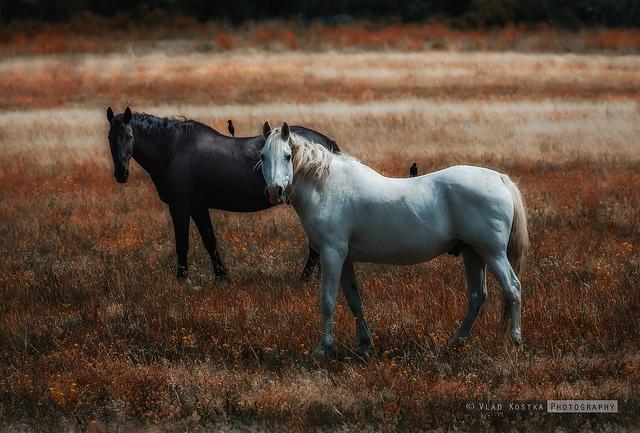Are the two horses the same color?
Give a very brief answer. No. Why is one horse smaller than the other?
Keep it brief. Genetics. IS the horse a solid color?
Write a very short answer. Yes. How many horses in the field?
Give a very brief answer. 2. What season is it likely?
Be succinct. Fall. Are the horses on a hill?
Keep it brief. No. Where are the horses staring?
Be succinct. At camera. What animal is in the foreground?
Give a very brief answer. Horse. 